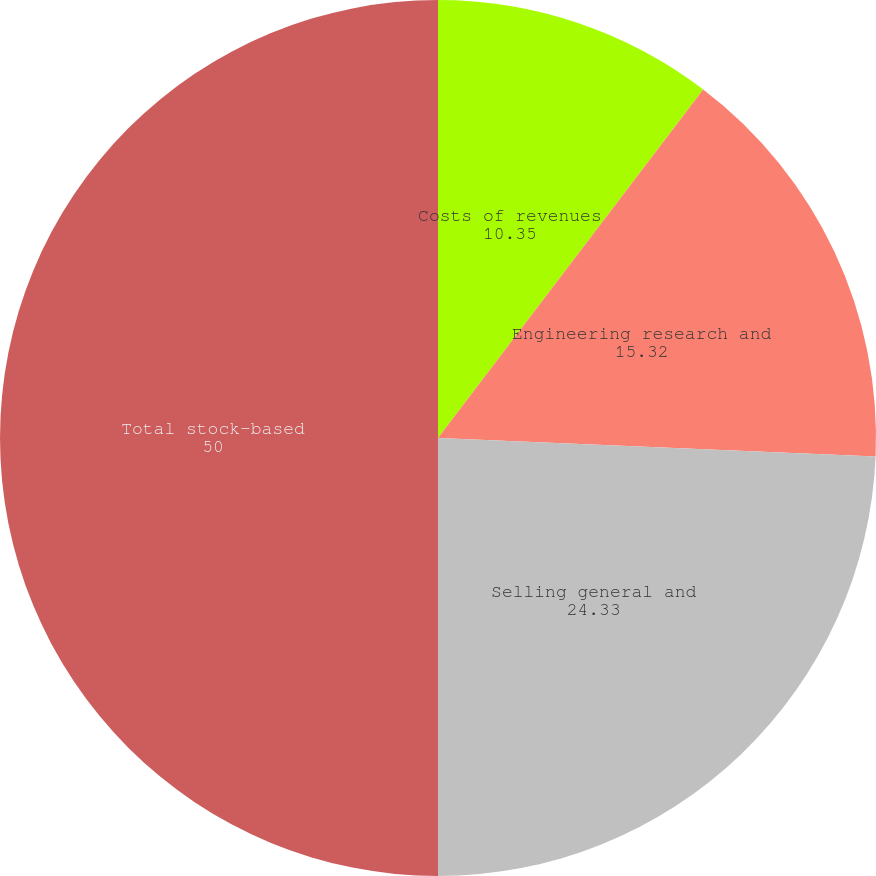<chart> <loc_0><loc_0><loc_500><loc_500><pie_chart><fcel>Costs of revenues<fcel>Engineering research and<fcel>Selling general and<fcel>Total stock-based<nl><fcel>10.35%<fcel>15.32%<fcel>24.33%<fcel>50.0%<nl></chart> 